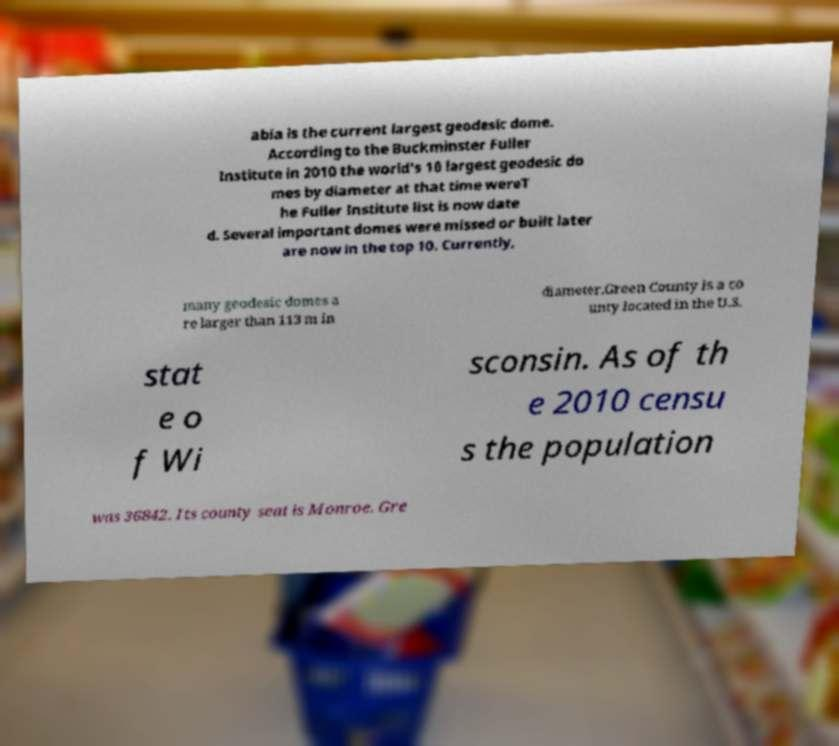For documentation purposes, I need the text within this image transcribed. Could you provide that? abia is the current largest geodesic dome. According to the Buckminster Fuller Institute in 2010 the world's 10 largest geodesic do mes by diameter at that time wereT he Fuller Institute list is now date d. Several important domes were missed or built later are now in the top 10. Currently, many geodesic domes a re larger than 113 m in diameter.Green County is a co unty located in the U.S. stat e o f Wi sconsin. As of th e 2010 censu s the population was 36842. Its county seat is Monroe. Gre 